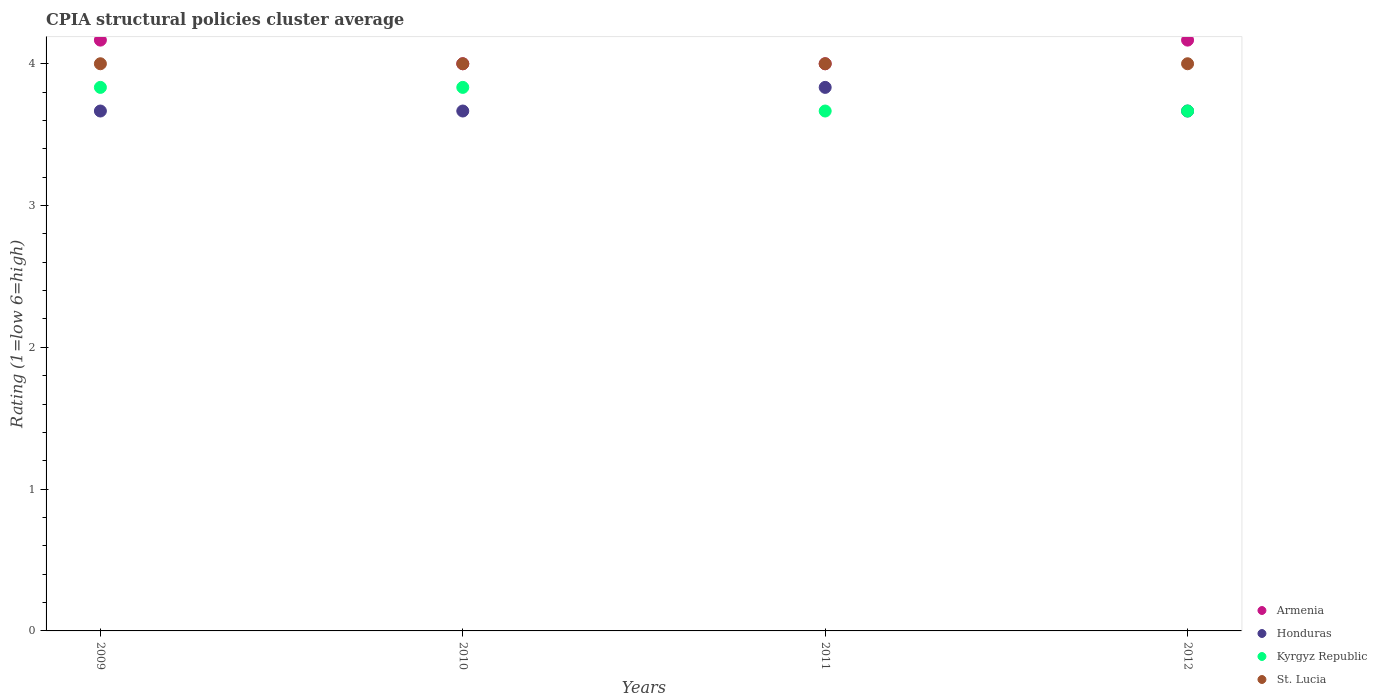Is the number of dotlines equal to the number of legend labels?
Give a very brief answer. Yes. Across all years, what is the maximum CPIA rating in Armenia?
Your answer should be compact. 4.17. Across all years, what is the minimum CPIA rating in Kyrgyz Republic?
Provide a succinct answer. 3.67. In which year was the CPIA rating in Armenia minimum?
Give a very brief answer. 2010. What is the total CPIA rating in Honduras in the graph?
Give a very brief answer. 14.83. What is the difference between the CPIA rating in Honduras in 2010 and that in 2011?
Offer a terse response. -0.17. What is the difference between the CPIA rating in Armenia in 2012 and the CPIA rating in St. Lucia in 2009?
Offer a very short reply. 0.17. What is the average CPIA rating in Kyrgyz Republic per year?
Ensure brevity in your answer.  3.75. In the year 2012, what is the difference between the CPIA rating in St. Lucia and CPIA rating in Honduras?
Your answer should be compact. 0.33. In how many years, is the CPIA rating in Armenia greater than 1.2?
Provide a short and direct response. 4. What is the ratio of the CPIA rating in St. Lucia in 2009 to that in 2012?
Your response must be concise. 1. Is the CPIA rating in Honduras in 2009 less than that in 2012?
Your response must be concise. No. What is the difference between the highest and the second highest CPIA rating in Honduras?
Provide a succinct answer. 0.17. What is the difference between the highest and the lowest CPIA rating in Honduras?
Keep it short and to the point. 0.17. Is the sum of the CPIA rating in Honduras in 2010 and 2011 greater than the maximum CPIA rating in Kyrgyz Republic across all years?
Offer a very short reply. Yes. Is it the case that in every year, the sum of the CPIA rating in Armenia and CPIA rating in St. Lucia  is greater than the sum of CPIA rating in Kyrgyz Republic and CPIA rating in Honduras?
Provide a succinct answer. Yes. Is it the case that in every year, the sum of the CPIA rating in Armenia and CPIA rating in St. Lucia  is greater than the CPIA rating in Kyrgyz Republic?
Your response must be concise. Yes. Is the CPIA rating in St. Lucia strictly greater than the CPIA rating in Armenia over the years?
Make the answer very short. No. How many years are there in the graph?
Make the answer very short. 4. What is the difference between two consecutive major ticks on the Y-axis?
Your answer should be very brief. 1. Are the values on the major ticks of Y-axis written in scientific E-notation?
Your answer should be compact. No. Does the graph contain any zero values?
Ensure brevity in your answer.  No. Where does the legend appear in the graph?
Keep it short and to the point. Bottom right. How are the legend labels stacked?
Offer a terse response. Vertical. What is the title of the graph?
Offer a terse response. CPIA structural policies cluster average. What is the label or title of the X-axis?
Ensure brevity in your answer.  Years. What is the Rating (1=low 6=high) of Armenia in 2009?
Make the answer very short. 4.17. What is the Rating (1=low 6=high) in Honduras in 2009?
Offer a very short reply. 3.67. What is the Rating (1=low 6=high) of Kyrgyz Republic in 2009?
Offer a terse response. 3.83. What is the Rating (1=low 6=high) of Armenia in 2010?
Provide a short and direct response. 4. What is the Rating (1=low 6=high) in Honduras in 2010?
Ensure brevity in your answer.  3.67. What is the Rating (1=low 6=high) in Kyrgyz Republic in 2010?
Ensure brevity in your answer.  3.83. What is the Rating (1=low 6=high) in Honduras in 2011?
Your answer should be compact. 3.83. What is the Rating (1=low 6=high) in Kyrgyz Republic in 2011?
Your answer should be compact. 3.67. What is the Rating (1=low 6=high) in St. Lucia in 2011?
Provide a short and direct response. 4. What is the Rating (1=low 6=high) of Armenia in 2012?
Offer a very short reply. 4.17. What is the Rating (1=low 6=high) of Honduras in 2012?
Provide a succinct answer. 3.67. What is the Rating (1=low 6=high) of Kyrgyz Republic in 2012?
Your answer should be very brief. 3.67. Across all years, what is the maximum Rating (1=low 6=high) of Armenia?
Your answer should be compact. 4.17. Across all years, what is the maximum Rating (1=low 6=high) of Honduras?
Ensure brevity in your answer.  3.83. Across all years, what is the maximum Rating (1=low 6=high) in Kyrgyz Republic?
Keep it short and to the point. 3.83. Across all years, what is the maximum Rating (1=low 6=high) in St. Lucia?
Provide a succinct answer. 4. Across all years, what is the minimum Rating (1=low 6=high) of Armenia?
Your answer should be compact. 4. Across all years, what is the minimum Rating (1=low 6=high) in Honduras?
Your answer should be compact. 3.67. Across all years, what is the minimum Rating (1=low 6=high) in Kyrgyz Republic?
Ensure brevity in your answer.  3.67. Across all years, what is the minimum Rating (1=low 6=high) in St. Lucia?
Provide a succinct answer. 4. What is the total Rating (1=low 6=high) of Armenia in the graph?
Keep it short and to the point. 16.33. What is the total Rating (1=low 6=high) of Honduras in the graph?
Give a very brief answer. 14.83. What is the total Rating (1=low 6=high) of Kyrgyz Republic in the graph?
Keep it short and to the point. 15. What is the difference between the Rating (1=low 6=high) in Kyrgyz Republic in 2009 and that in 2010?
Your answer should be very brief. 0. What is the difference between the Rating (1=low 6=high) of Kyrgyz Republic in 2009 and that in 2011?
Give a very brief answer. 0.17. What is the difference between the Rating (1=low 6=high) in St. Lucia in 2009 and that in 2011?
Your answer should be compact. 0. What is the difference between the Rating (1=low 6=high) in St. Lucia in 2009 and that in 2012?
Keep it short and to the point. 0. What is the difference between the Rating (1=low 6=high) in Honduras in 2010 and that in 2011?
Ensure brevity in your answer.  -0.17. What is the difference between the Rating (1=low 6=high) in Honduras in 2010 and that in 2012?
Your response must be concise. 0. What is the difference between the Rating (1=low 6=high) of Kyrgyz Republic in 2010 and that in 2012?
Offer a very short reply. 0.17. What is the difference between the Rating (1=low 6=high) in St. Lucia in 2010 and that in 2012?
Make the answer very short. 0. What is the difference between the Rating (1=low 6=high) of Kyrgyz Republic in 2011 and that in 2012?
Give a very brief answer. 0. What is the difference between the Rating (1=low 6=high) of Armenia in 2009 and the Rating (1=low 6=high) of Honduras in 2010?
Give a very brief answer. 0.5. What is the difference between the Rating (1=low 6=high) in Armenia in 2009 and the Rating (1=low 6=high) in St. Lucia in 2010?
Your answer should be very brief. 0.17. What is the difference between the Rating (1=low 6=high) in Honduras in 2009 and the Rating (1=low 6=high) in Kyrgyz Republic in 2010?
Provide a short and direct response. -0.17. What is the difference between the Rating (1=low 6=high) of Armenia in 2009 and the Rating (1=low 6=high) of Honduras in 2011?
Ensure brevity in your answer.  0.33. What is the difference between the Rating (1=low 6=high) of Armenia in 2009 and the Rating (1=low 6=high) of St. Lucia in 2011?
Your response must be concise. 0.17. What is the difference between the Rating (1=low 6=high) of Kyrgyz Republic in 2009 and the Rating (1=low 6=high) of St. Lucia in 2011?
Your answer should be compact. -0.17. What is the difference between the Rating (1=low 6=high) of Armenia in 2009 and the Rating (1=low 6=high) of Kyrgyz Republic in 2012?
Offer a very short reply. 0.5. What is the difference between the Rating (1=low 6=high) in Armenia in 2009 and the Rating (1=low 6=high) in St. Lucia in 2012?
Offer a terse response. 0.17. What is the difference between the Rating (1=low 6=high) of Honduras in 2009 and the Rating (1=low 6=high) of Kyrgyz Republic in 2012?
Keep it short and to the point. 0. What is the difference between the Rating (1=low 6=high) of Kyrgyz Republic in 2009 and the Rating (1=low 6=high) of St. Lucia in 2012?
Your answer should be very brief. -0.17. What is the difference between the Rating (1=low 6=high) in Armenia in 2010 and the Rating (1=low 6=high) in Honduras in 2011?
Ensure brevity in your answer.  0.17. What is the difference between the Rating (1=low 6=high) in Armenia in 2010 and the Rating (1=low 6=high) in Kyrgyz Republic in 2011?
Offer a terse response. 0.33. What is the difference between the Rating (1=low 6=high) of Armenia in 2010 and the Rating (1=low 6=high) of St. Lucia in 2011?
Provide a short and direct response. 0. What is the difference between the Rating (1=low 6=high) of Honduras in 2010 and the Rating (1=low 6=high) of Kyrgyz Republic in 2011?
Make the answer very short. 0. What is the difference between the Rating (1=low 6=high) in Kyrgyz Republic in 2010 and the Rating (1=low 6=high) in St. Lucia in 2011?
Keep it short and to the point. -0.17. What is the difference between the Rating (1=low 6=high) of Armenia in 2010 and the Rating (1=low 6=high) of St. Lucia in 2012?
Keep it short and to the point. 0. What is the difference between the Rating (1=low 6=high) in Honduras in 2010 and the Rating (1=low 6=high) in Kyrgyz Republic in 2012?
Your response must be concise. 0. What is the difference between the Rating (1=low 6=high) of Honduras in 2010 and the Rating (1=low 6=high) of St. Lucia in 2012?
Offer a very short reply. -0.33. What is the difference between the Rating (1=low 6=high) in Armenia in 2011 and the Rating (1=low 6=high) in St. Lucia in 2012?
Keep it short and to the point. 0. What is the difference between the Rating (1=low 6=high) in Honduras in 2011 and the Rating (1=low 6=high) in St. Lucia in 2012?
Your response must be concise. -0.17. What is the difference between the Rating (1=low 6=high) in Kyrgyz Republic in 2011 and the Rating (1=low 6=high) in St. Lucia in 2012?
Offer a terse response. -0.33. What is the average Rating (1=low 6=high) in Armenia per year?
Provide a short and direct response. 4.08. What is the average Rating (1=low 6=high) of Honduras per year?
Ensure brevity in your answer.  3.71. What is the average Rating (1=low 6=high) in Kyrgyz Republic per year?
Make the answer very short. 3.75. What is the average Rating (1=low 6=high) of St. Lucia per year?
Give a very brief answer. 4. In the year 2009, what is the difference between the Rating (1=low 6=high) in Armenia and Rating (1=low 6=high) in Honduras?
Your answer should be compact. 0.5. In the year 2009, what is the difference between the Rating (1=low 6=high) of Armenia and Rating (1=low 6=high) of Kyrgyz Republic?
Your answer should be very brief. 0.33. In the year 2009, what is the difference between the Rating (1=low 6=high) in Armenia and Rating (1=low 6=high) in St. Lucia?
Make the answer very short. 0.17. In the year 2010, what is the difference between the Rating (1=low 6=high) in Armenia and Rating (1=low 6=high) in Honduras?
Your response must be concise. 0.33. In the year 2010, what is the difference between the Rating (1=low 6=high) in Armenia and Rating (1=low 6=high) in Kyrgyz Republic?
Your response must be concise. 0.17. In the year 2010, what is the difference between the Rating (1=low 6=high) of Honduras and Rating (1=low 6=high) of Kyrgyz Republic?
Offer a terse response. -0.17. In the year 2011, what is the difference between the Rating (1=low 6=high) of Armenia and Rating (1=low 6=high) of Honduras?
Offer a very short reply. 0.17. In the year 2011, what is the difference between the Rating (1=low 6=high) in Armenia and Rating (1=low 6=high) in St. Lucia?
Keep it short and to the point. 0. In the year 2011, what is the difference between the Rating (1=low 6=high) of Honduras and Rating (1=low 6=high) of Kyrgyz Republic?
Keep it short and to the point. 0.17. In the year 2011, what is the difference between the Rating (1=low 6=high) in Honduras and Rating (1=low 6=high) in St. Lucia?
Your response must be concise. -0.17. In the year 2012, what is the difference between the Rating (1=low 6=high) in Armenia and Rating (1=low 6=high) in Kyrgyz Republic?
Give a very brief answer. 0.5. In the year 2012, what is the difference between the Rating (1=low 6=high) of Honduras and Rating (1=low 6=high) of St. Lucia?
Keep it short and to the point. -0.33. In the year 2012, what is the difference between the Rating (1=low 6=high) of Kyrgyz Republic and Rating (1=low 6=high) of St. Lucia?
Offer a terse response. -0.33. What is the ratio of the Rating (1=low 6=high) of Armenia in 2009 to that in 2010?
Ensure brevity in your answer.  1.04. What is the ratio of the Rating (1=low 6=high) of Honduras in 2009 to that in 2010?
Provide a succinct answer. 1. What is the ratio of the Rating (1=low 6=high) of Armenia in 2009 to that in 2011?
Keep it short and to the point. 1.04. What is the ratio of the Rating (1=low 6=high) in Honduras in 2009 to that in 2011?
Offer a terse response. 0.96. What is the ratio of the Rating (1=low 6=high) of Kyrgyz Republic in 2009 to that in 2011?
Your answer should be compact. 1.05. What is the ratio of the Rating (1=low 6=high) in Armenia in 2009 to that in 2012?
Your answer should be very brief. 1. What is the ratio of the Rating (1=low 6=high) of Honduras in 2009 to that in 2012?
Your answer should be very brief. 1. What is the ratio of the Rating (1=low 6=high) in Kyrgyz Republic in 2009 to that in 2012?
Your response must be concise. 1.05. What is the ratio of the Rating (1=low 6=high) in Honduras in 2010 to that in 2011?
Offer a terse response. 0.96. What is the ratio of the Rating (1=low 6=high) of Kyrgyz Republic in 2010 to that in 2011?
Ensure brevity in your answer.  1.05. What is the ratio of the Rating (1=low 6=high) in Kyrgyz Republic in 2010 to that in 2012?
Make the answer very short. 1.05. What is the ratio of the Rating (1=low 6=high) in Honduras in 2011 to that in 2012?
Offer a terse response. 1.05. What is the difference between the highest and the second highest Rating (1=low 6=high) in Honduras?
Your response must be concise. 0.17. What is the difference between the highest and the second highest Rating (1=low 6=high) in Kyrgyz Republic?
Provide a short and direct response. 0. What is the difference between the highest and the lowest Rating (1=low 6=high) in Honduras?
Offer a very short reply. 0.17. What is the difference between the highest and the lowest Rating (1=low 6=high) in Kyrgyz Republic?
Offer a terse response. 0.17. 